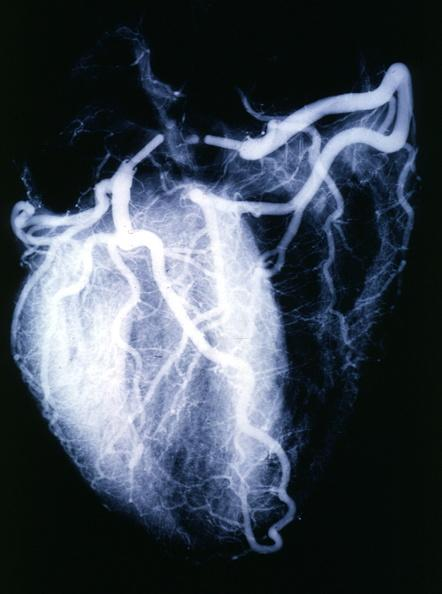what is present?
Answer the question using a single word or phrase. Angiogram 